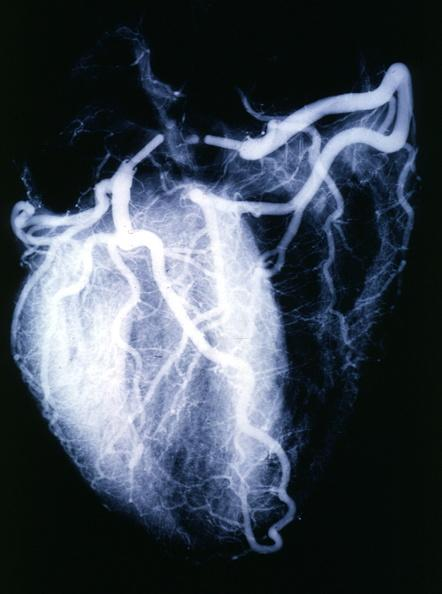what is present?
Answer the question using a single word or phrase. Angiogram 